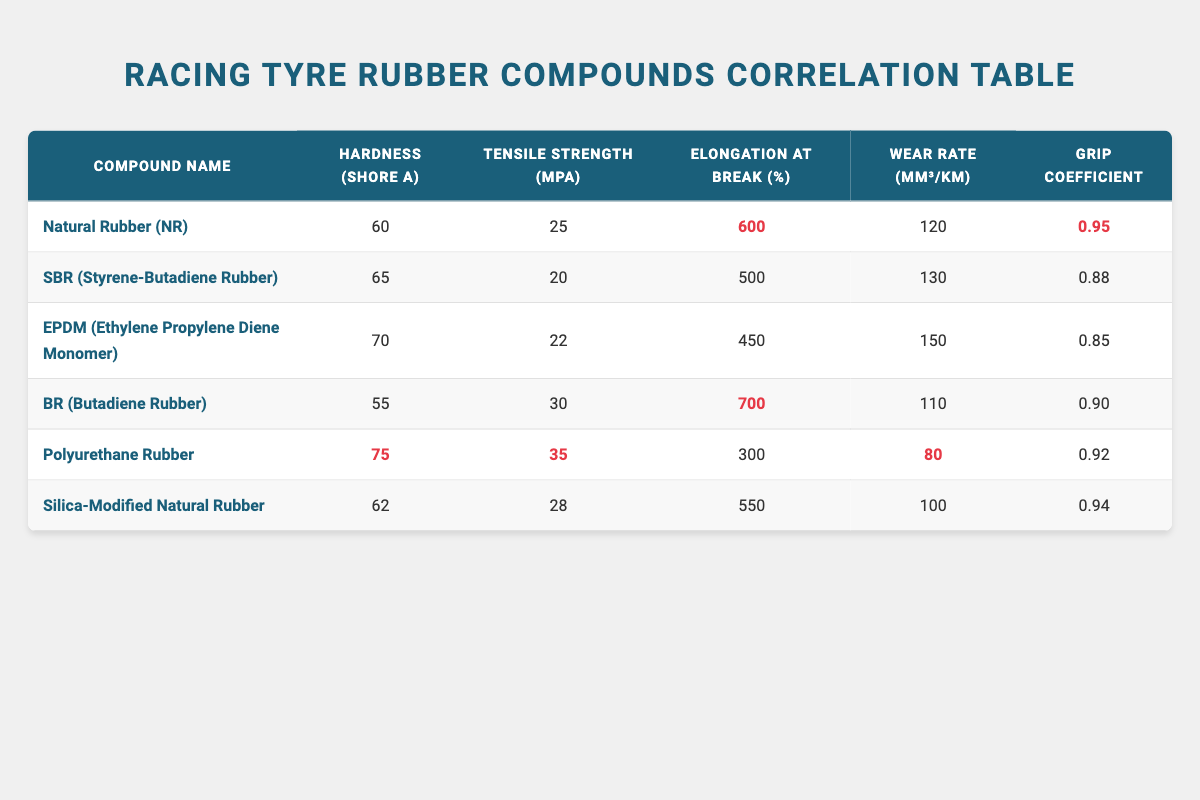What is the hardness of Polyurethane Rubber? Looking at the table, find the row for Polyurethane Rubber and check the corresponding value under the hardness column, which is listed as 75.
Answer: 75 Which rubber compound has the highest tensile strength? Review the tensile strength column for each compound and identify the highest value. In the table, Polyurethane Rubber has the highest tensile strength at 35 MPa.
Answer: Polyurethane Rubber Is the wear rate of SBR higher than that of Natural Rubber? Compare the wear rate values for both SBR (130 mm³/km) and Natural Rubber (120 mm³/km). Since 130 is greater than 120, SBR has a higher wear rate.
Answer: Yes What is the average elongation at break of all the compounds? To find the average elongation at break, sum the elongation values: 600 + 500 + 450 + 700 + 300 + 550 = 3100. Then, divide by the number of compounds, which is 6: 3100 / 6 = 516.67 (rounded to 517).
Answer: 517 Which rubber compound has the lowest grip coefficient? Check the grip coefficient column for each compound to find the lowest value. In the table, EPDM has the lowest grip coefficient at 0.85.
Answer: EPDM Is Natural Rubber the only compound with an elongation at break greater than 600 percent? Examine the elongation at break values: Natural Rubber (600), SBR (500), EPDM (450), BR (700), Polyurethane Rubber (300), and Silica-Modified Natural Rubber (550). The value for BR is also greater at 700, so Natural Rubber is not the only one.
Answer: No What is the difference in wear rate between Polyurethane Rubber and BR? Find the wear rates: Polyurethane Rubber (80 mm³/km) and BR (110 mm³/km). Calculate the difference: 110 - 80 = 30 mm³/km.
Answer: 30 mm³/km Which compound has a hardness less than or equal to 65? Look through the hardness column and check for compounds with values less than or equal to 65: Natural Rubber (60), SBR (65), and BR (55) fit this criteria.
Answer: Natural Rubber, SBR, BR What is the relationship between tensile strength and grip coefficient in the table? To analyze the relationship, compile the tensile strength and grip coefficient values of each compound. Check if a pattern emerges, for example, if higher tensile strength correlates to higher grip coefficients. From the rows, it appears while tensile strength increases, grip coefficient does not show consistent trends, indicating a more complex relationship.
Answer: No clear relationship 